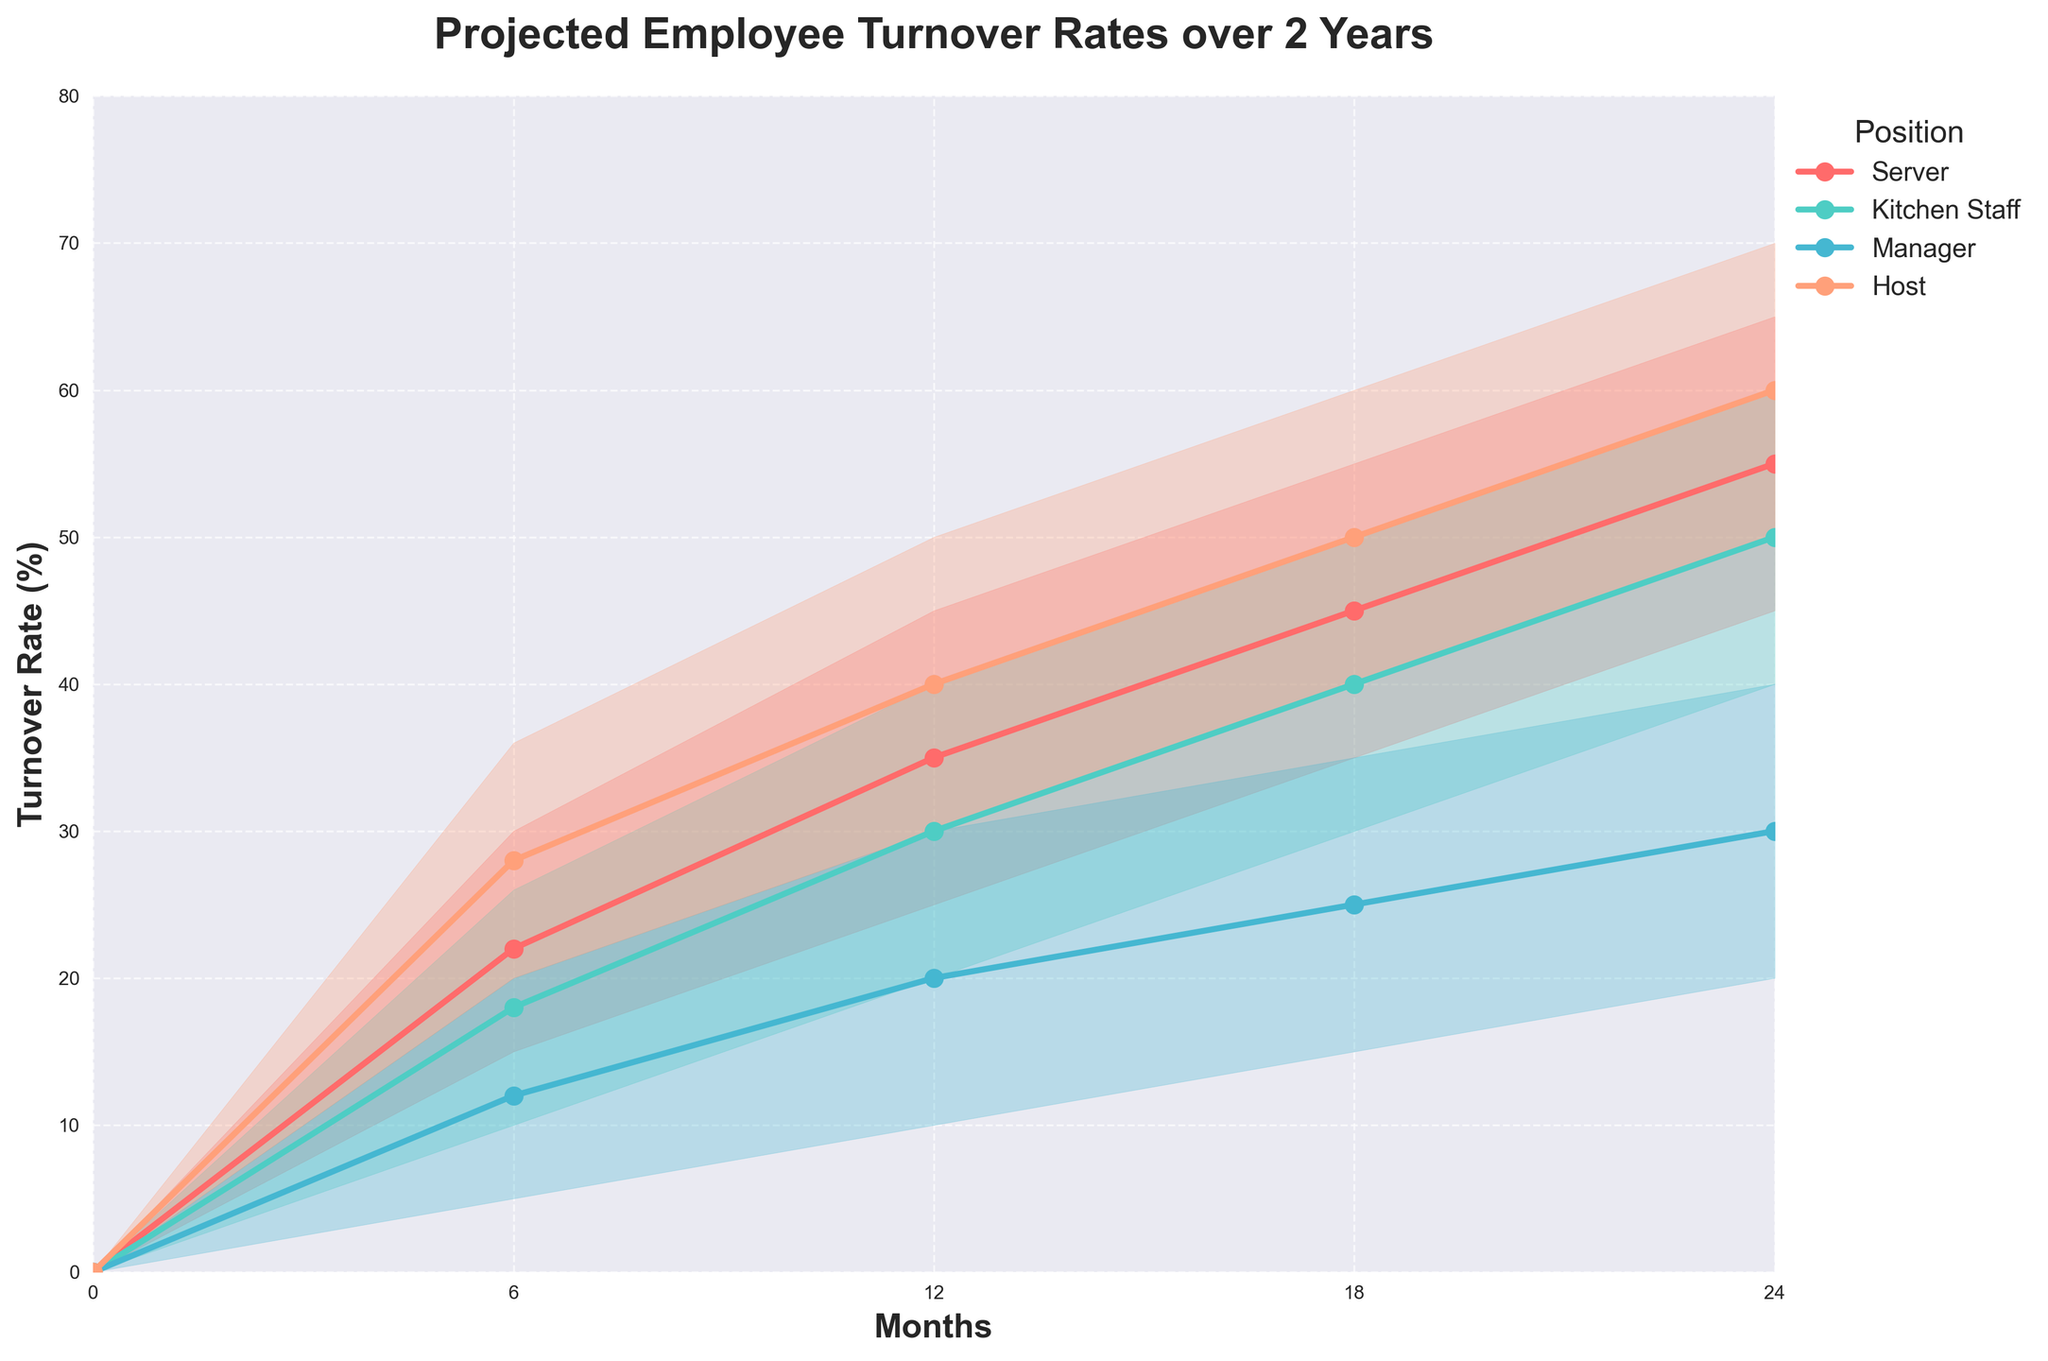What is the title of the figure? The title is typically found at the top of the figure and describes the main subject. By looking at the top of the chart, we can see the title.
Answer: Projected Employee Turnover Rates over 2 Years Which position has the highest projected turnover rate after 24 months in the high scenario? We need to look at the high scenario values for each position at the 24-month mark. The values are Servers 65%, Kitchen Staff 60%, Managers 40%, Hosts 70%. Hosts have the highest rate.
Answer: Hosts What is the turnover rate for Kitchen Staff after 18 months in the low-mid scenario? Locate the time point of 18 months for Kitchen Staff and then look for the low-mid scenario, which corresponds to 35%.
Answer: 35% Compare the projected turnover rate for Managers and Hosts at the 12-month mark in the mid scenario. Which is higher? Check the turnover rates for the managers and hosts in the mid scenario for 12 months. Managers is 20% and Hosts is 40%. Hosts have a higher rate.
Answer: Hosts By how much does the high scenario turnover rate for Servers increase from 6 months to 24 months? Find the high scenario turnover rates for Servers at 6 months (30%) and 24 months (65%), then calculate the difference (65% - 30% = 35%).
Answer: 35% Which position shows the lowest projected turnover rate at the 6-month mark in the low scenario? Compare the low scenario rates for all positions at the 6-month mark: Servers 15%, Kitchen Staff 10%, Managers 5%, Hosts 20%. Managers have the lowest rate.
Answer: Managers What is the average mid-scenario turnover rate for all positions at 12 months? The mid-scenario values at 12 months are Servers 35%, Kitchen Staff 30%, Managers 20%, Hosts 40%. Calculate the average: (35% + 30% + 20% + 40%) / 4 = 31.25%.
Answer: 31.25% In the mid-high scenario, which position shows the greatest increase in turnover rate between 6 and 18 months? Calculate the increase for each position: Servers (50% - 26% = 24%), Kitchen Staff (45% - 22% = 23%), Managers (30% - 16% = 14%), Hosts (55% - 32% = 23%). Servers show the greatest increase of 24%.
Answer: Servers Based on the chart, would Kitchen Staff or Servers be more affected by internal retention strategies over 24 months, if they prove equally effective? Analyzing the high scenario for both: Kitchen Staff 60%, Servers 65%. Since Servers have a higher maximum rate, they could benefit more from effective strategies.
Answer: Servers 